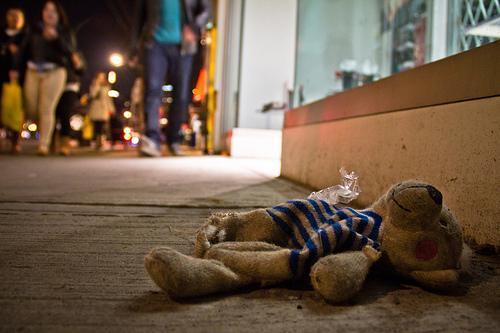How many bears are there?
Give a very brief answer. 1. 